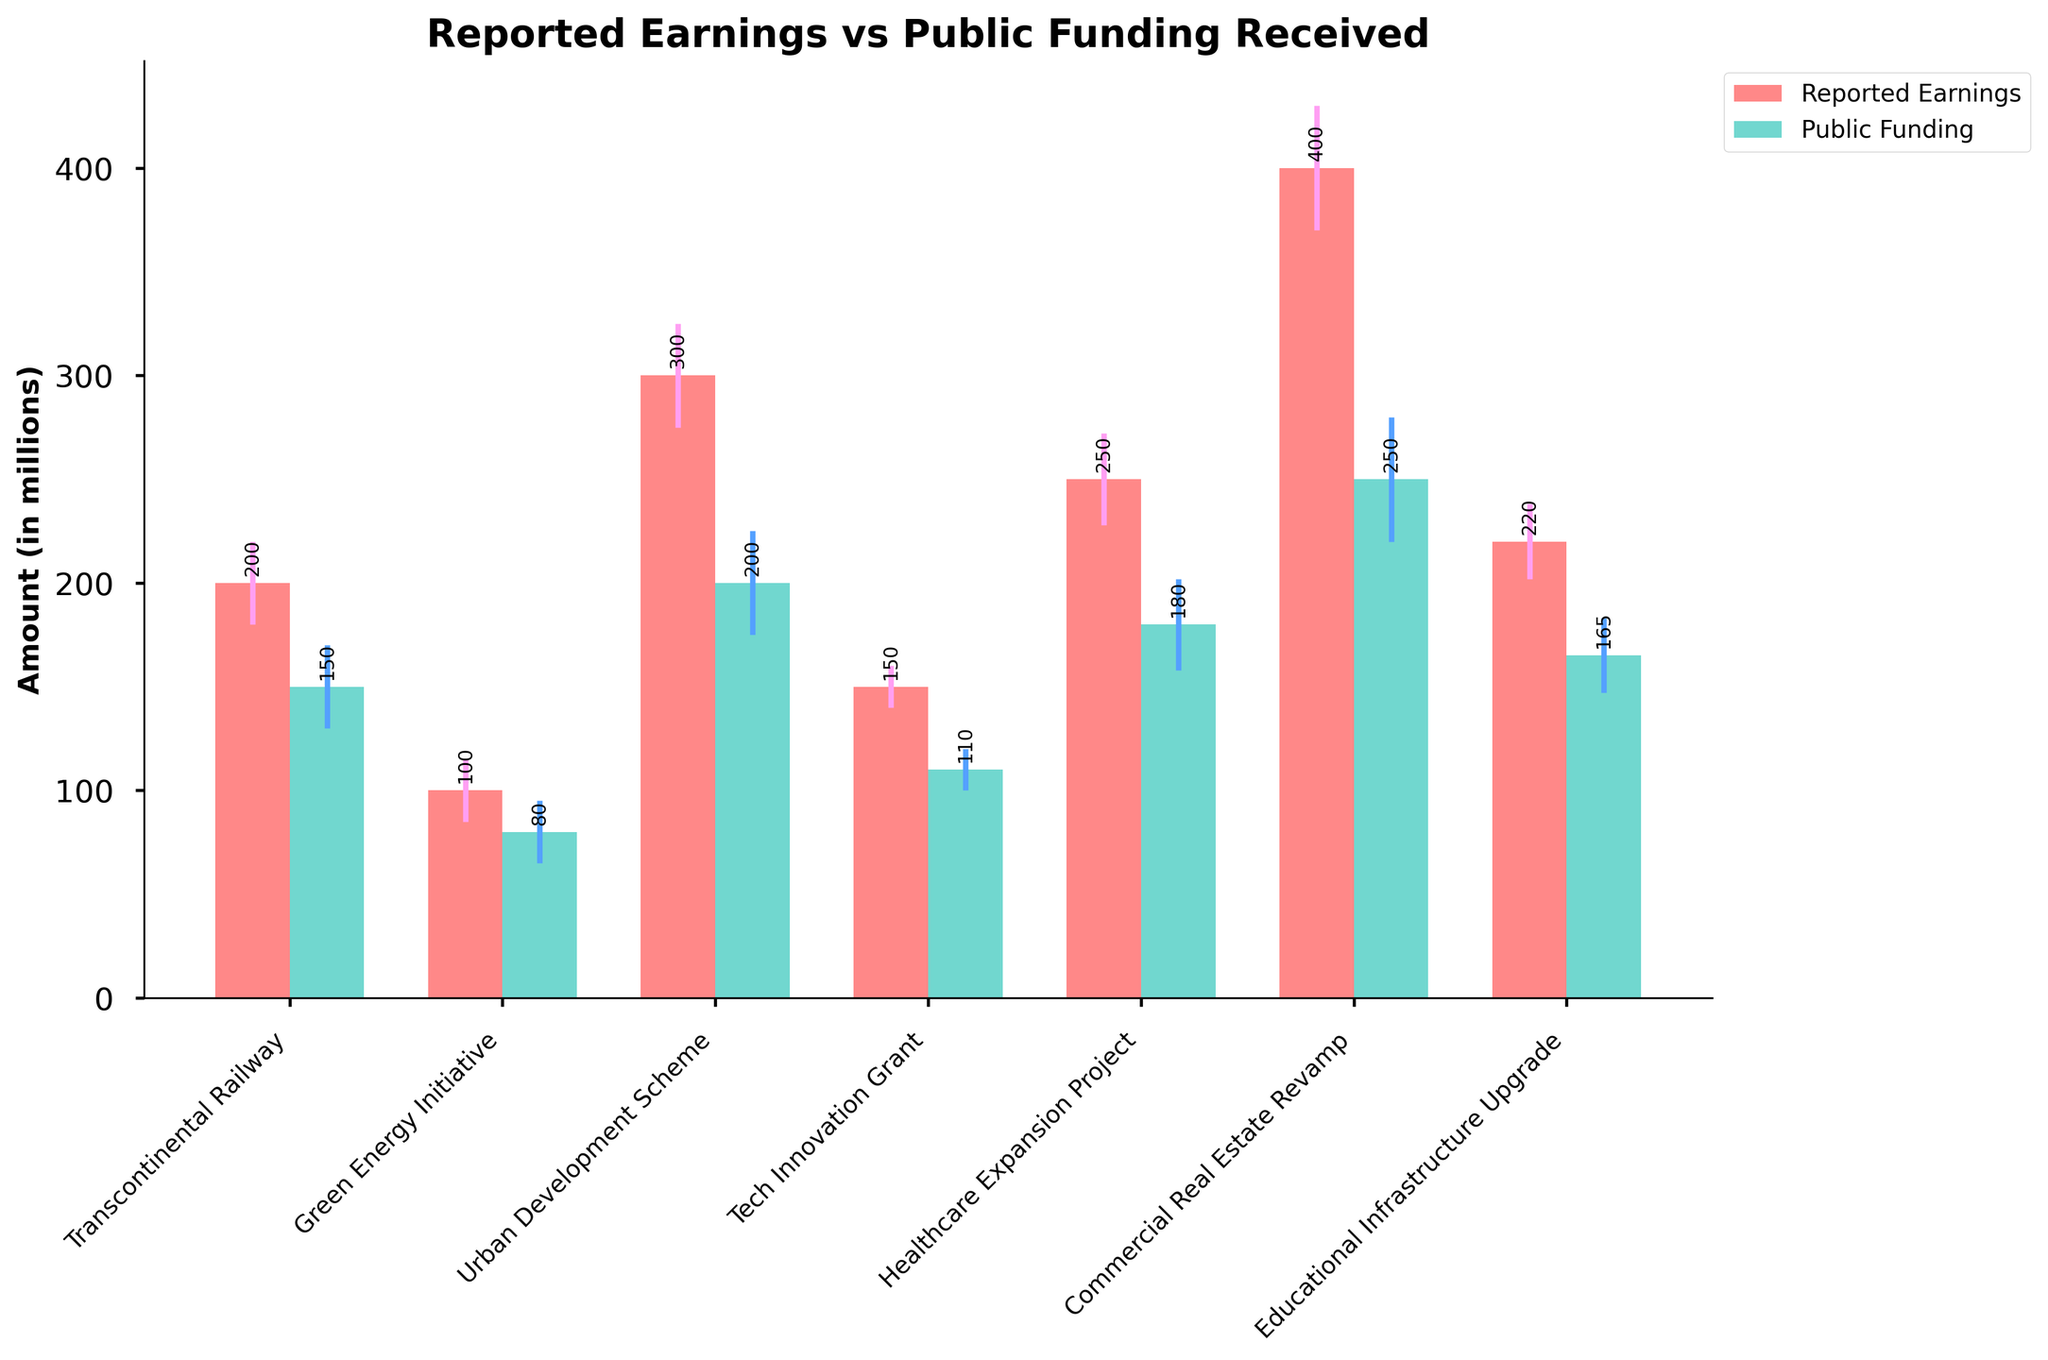what is the title of the bar chart? The title is usually displayed at the top of the bar chart. It provides an overview of what the chart represents. In this case, it tells us that the chart is comparing reported earnings with public funding received for different projects.
Answer: Reported Earnings vs Public Funding Received Which project has the highest reported earnings? Identify the tallest bar representing reported earnings, which corresponds to the project with the highest reported earnings. The tallest bar for reported earnings is for Commercial Real Estate Revamp.
Answer: Commercial Real Estate Revamp What are the colors representing reported earnings and public funding, respectively? The colors are distinguishable in the chart. The bars representing reported earnings are in a pinkish-red color while the bars representing public funding are in a teal color.
Answer: Pinkish-red, teal Which project has the smallest difference between reported earnings and public funding received? Calculate the difference for each project by subtracting the public funding received from reported earnings. The smallest difference is found for Tech Innovation Grant [(150 - 110) = 40].
Answer: Tech Innovation Grant How many projects are represented in this bar chart? Count the number of bars in either the reported earnings or public funding group, as each project has a bar in both groups.
Answer: 7 For the Green Energy Initiative, what is the approximate error value for public funding received? Find the bar for public funding of Green Energy Initiative and look at the error bars that extend from it vertically. The error is represented in the dataset as well, which is 15 million.
Answer: 15 million What is the total public funding received for all projects combined? Add the public funding of all projects: 150 + 80 + 200 + 110 + 180 + 250 + 165. This results in a total of 1135 million.
Answer: 1135 million Which project has a larger reported earning compared to public finding with the highest error bar? Look at the bars for projects, compare their reported earnings and public funding, and cross-check the error bars. The tallest error bar appears for Commercial Real Estate Revamp, which also has a larger reported earnings compared to public funding.
Answer: Commercial Real Estate Revamp Compare the reported earnings and public funding received for the Healthcare Expansion Project. Which is higher, and by how much? Look at the bars for the Healthcare Expansion Project. Reported earnings is 250 million and public funding is 180 million. The difference is 250 - 180 = 70 million.
Answer: Reported earnings is higher by 70 million 